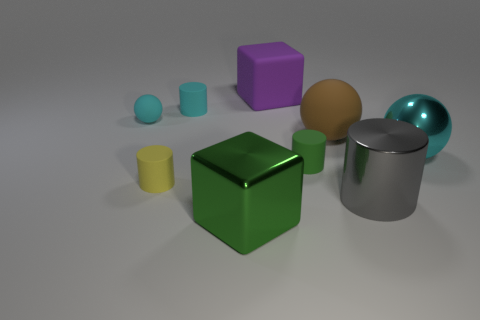Subtract all gray metal cylinders. How many cylinders are left? 3 Add 1 big cyan metallic objects. How many objects exist? 10 Subtract all cyan balls. How many balls are left? 1 Subtract all brown cylinders. How many cyan balls are left? 2 Subtract 1 blocks. How many blocks are left? 1 Subtract all cylinders. How many objects are left? 5 Subtract all brown matte things. Subtract all tiny green matte things. How many objects are left? 7 Add 8 purple blocks. How many purple blocks are left? 9 Add 8 yellow rubber things. How many yellow rubber things exist? 9 Subtract 0 yellow cubes. How many objects are left? 9 